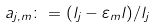<formula> <loc_0><loc_0><loc_500><loc_500>a _ { j , m } \colon = ( l _ { j } - \varepsilon _ { m } l ) / l _ { j }</formula> 